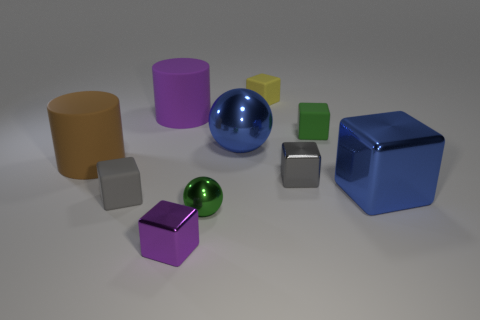Is the number of blue metal objects that are left of the small purple metal thing less than the number of large gray metallic cubes?
Offer a terse response. No. There is a green thing that is in front of the small gray cube that is left of the tiny metal block to the right of the large metallic sphere; what is its shape?
Give a very brief answer. Sphere. There is a gray cube to the right of the small green ball; how big is it?
Your answer should be very brief. Small. There is a gray rubber object that is the same size as the purple shiny thing; what shape is it?
Offer a terse response. Cube. How many objects are small green things or cylinders in front of the green rubber block?
Provide a succinct answer. 3. How many large blue spheres are left of the purple thing that is in front of the tiny metal cube behind the purple metallic object?
Your answer should be very brief. 0. There is a large ball that is made of the same material as the purple cube; what color is it?
Provide a succinct answer. Blue. Does the matte cylinder that is behind the blue metallic ball have the same size as the tiny yellow cube?
Provide a short and direct response. No. What number of objects are either big blue blocks or spheres?
Provide a short and direct response. 3. What is the material of the yellow thing behind the gray object behind the small object on the left side of the tiny purple thing?
Provide a succinct answer. Rubber. 